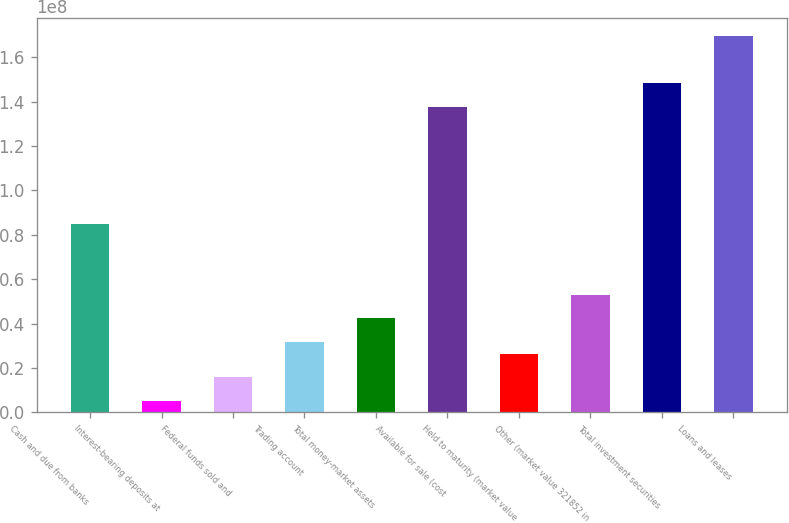Convert chart. <chart><loc_0><loc_0><loc_500><loc_500><bar_chart><fcel>Cash and due from banks<fcel>Interest-bearing deposits at<fcel>Federal funds sold and<fcel>Trading account<fcel>Total money-market assets<fcel>Available for sale (cost<fcel>Held to maturity (market value<fcel>Other (market value 321852 in<fcel>Total investment securities<fcel>Loans and leases<nl><fcel>8.46985e+07<fcel>5.29907e+06<fcel>1.58857e+07<fcel>3.17655e+07<fcel>4.23521e+07<fcel>1.37631e+08<fcel>2.64722e+07<fcel>5.29387e+07<fcel>1.48218e+08<fcel>1.69391e+08<nl></chart> 